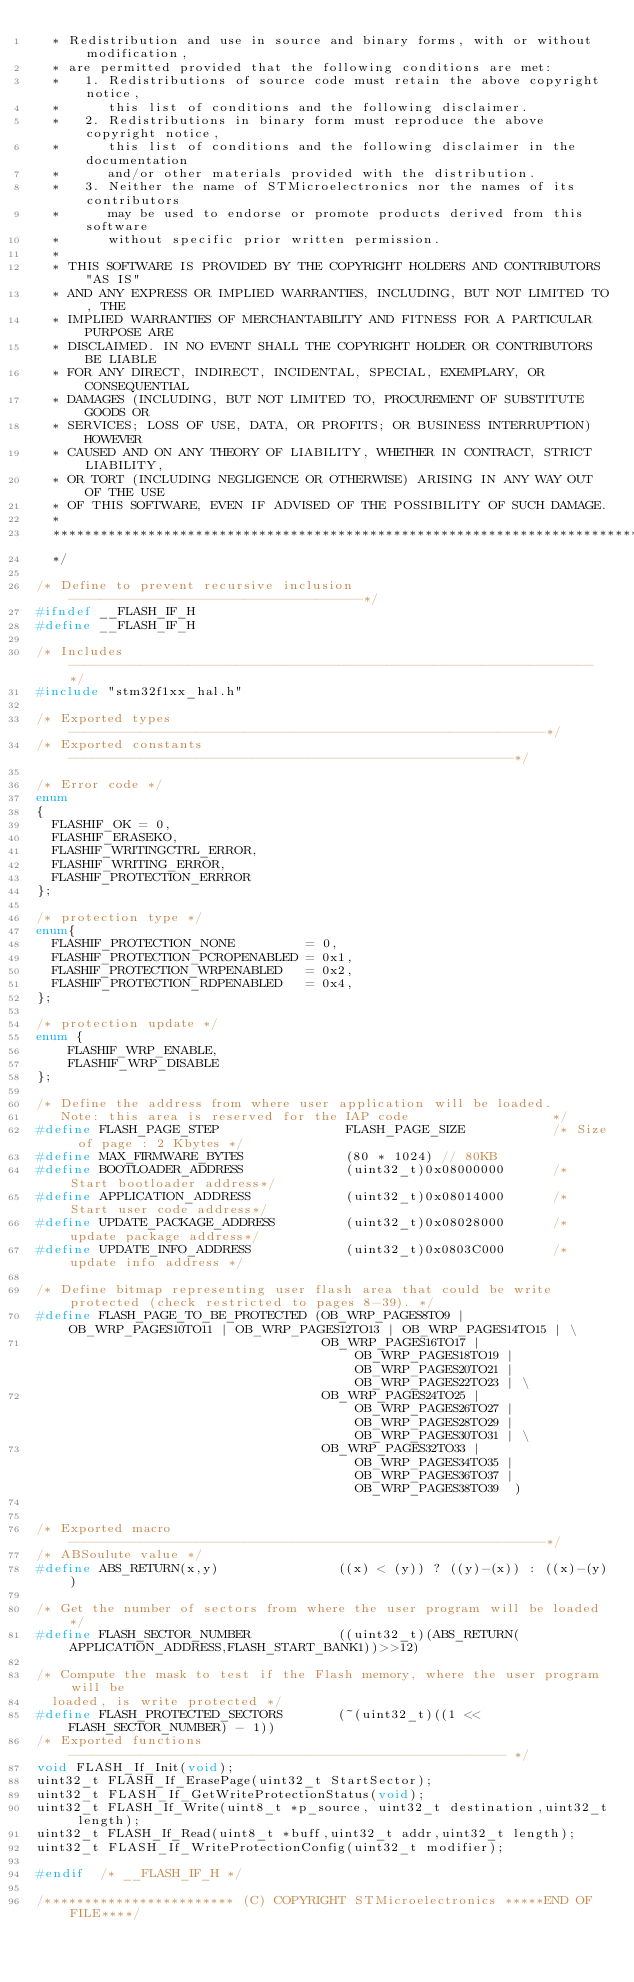Convert code to text. <code><loc_0><loc_0><loc_500><loc_500><_C_>  * Redistribution and use in source and binary forms, with or without modification,
  * are permitted provided that the following conditions are met:
  *   1. Redistributions of source code must retain the above copyright notice,
  *      this list of conditions and the following disclaimer.
  *   2. Redistributions in binary form must reproduce the above copyright notice,
  *      this list of conditions and the following disclaimer in the documentation
  *      and/or other materials provided with the distribution.
  *   3. Neither the name of STMicroelectronics nor the names of its contributors
  *      may be used to endorse or promote products derived from this software
  *      without specific prior written permission.
  *
  * THIS SOFTWARE IS PROVIDED BY THE COPYRIGHT HOLDERS AND CONTRIBUTORS "AS IS"
  * AND ANY EXPRESS OR IMPLIED WARRANTIES, INCLUDING, BUT NOT LIMITED TO, THE
  * IMPLIED WARRANTIES OF MERCHANTABILITY AND FITNESS FOR A PARTICULAR PURPOSE ARE
  * DISCLAIMED. IN NO EVENT SHALL THE COPYRIGHT HOLDER OR CONTRIBUTORS BE LIABLE
  * FOR ANY DIRECT, INDIRECT, INCIDENTAL, SPECIAL, EXEMPLARY, OR CONSEQUENTIAL
  * DAMAGES (INCLUDING, BUT NOT LIMITED TO, PROCUREMENT OF SUBSTITUTE GOODS OR
  * SERVICES; LOSS OF USE, DATA, OR PROFITS; OR BUSINESS INTERRUPTION) HOWEVER
  * CAUSED AND ON ANY THEORY OF LIABILITY, WHETHER IN CONTRACT, STRICT LIABILITY,
  * OR TORT (INCLUDING NEGLIGENCE OR OTHERWISE) ARISING IN ANY WAY OUT OF THE USE
  * OF THIS SOFTWARE, EVEN IF ADVISED OF THE POSSIBILITY OF SUCH DAMAGE.
  *
  ******************************************************************************
  */

/* Define to prevent recursive inclusion -------------------------------------*/
#ifndef __FLASH_IF_H
#define __FLASH_IF_H

/* Includes ------------------------------------------------------------------*/
#include "stm32f1xx_hal.h"

/* Exported types ------------------------------------------------------------*/
/* Exported constants --------------------------------------------------------*/

/* Error code */
enum 
{
  FLASHIF_OK = 0,
  FLASHIF_ERASEKO,
  FLASHIF_WRITINGCTRL_ERROR,
  FLASHIF_WRITING_ERROR,
  FLASHIF_PROTECTION_ERRROR
};

/* protection type */  
enum{
  FLASHIF_PROTECTION_NONE         = 0,
  FLASHIF_PROTECTION_PCROPENABLED = 0x1,
  FLASHIF_PROTECTION_WRPENABLED   = 0x2,
  FLASHIF_PROTECTION_RDPENABLED   = 0x4,
};

/* protection update */
enum {
	FLASHIF_WRP_ENABLE,
	FLASHIF_WRP_DISABLE
};

/* Define the address from where user application will be loaded.
   Note: this area is reserved for the IAP code                  */
#define FLASH_PAGE_STEP                FLASH_PAGE_SIZE           /* Size of page : 2 Kbytes */
#define MAX_FIRMWARE_BYTES             (80 * 1024) // 80KB
#define BOOTLOADER_ADDRESS             (uint32_t)0x08000000      /* Start bootloader address*/
#define APPLICATION_ADDRESS            (uint32_t)0x08014000      /* Start user code address*/
#define UPDATE_PACKAGE_ADDRESS         (uint32_t)0x08028000      /* update package address*/
#define UPDATE_INFO_ADDRESS            (uint32_t)0x0803C000      /* update info address */

/* Define bitmap representing user flash area that could be write protected (check restricted to pages 8-39). */
#define FLASH_PAGE_TO_BE_PROTECTED (OB_WRP_PAGES8TO9 | OB_WRP_PAGES10TO11 | OB_WRP_PAGES12TO13 | OB_WRP_PAGES14TO15 | \
                                    OB_WRP_PAGES16TO17 | OB_WRP_PAGES18TO19 | OB_WRP_PAGES20TO21 | OB_WRP_PAGES22TO23 | \
                                    OB_WRP_PAGES24TO25 | OB_WRP_PAGES26TO27 | OB_WRP_PAGES28TO29 | OB_WRP_PAGES30TO31 | \
                                    OB_WRP_PAGES32TO33 | OB_WRP_PAGES34TO35 | OB_WRP_PAGES36TO37 | OB_WRP_PAGES38TO39  )  


/* Exported macro ------------------------------------------------------------*/
/* ABSoulute value */
#define ABS_RETURN(x,y)               ((x) < (y)) ? ((y)-(x)) : ((x)-(y))

/* Get the number of sectors from where the user program will be loaded */
#define FLASH_SECTOR_NUMBER           ((uint32_t)(ABS_RETURN(APPLICATION_ADDRESS,FLASH_START_BANK1))>>12)

/* Compute the mask to test if the Flash memory, where the user program will be
  loaded, is write protected */
#define FLASH_PROTECTED_SECTORS       (~(uint32_t)((1 << FLASH_SECTOR_NUMBER) - 1))
/* Exported functions ------------------------------------------------------- */
void FLASH_If_Init(void);
uint32_t FLASH_If_ErasePage(uint32_t StartSector);
uint32_t FLASH_If_GetWriteProtectionStatus(void);
uint32_t FLASH_If_Write(uint8_t *p_source, uint32_t destination,uint32_t length);
uint32_t FLASH_If_Read(uint8_t *buff,uint32_t addr,uint32_t length);
uint32_t FLASH_If_WriteProtectionConfig(uint32_t modifier);

#endif  /* __FLASH_IF_H */

/************************ (C) COPYRIGHT STMicroelectronics *****END OF FILE****/
</code> 